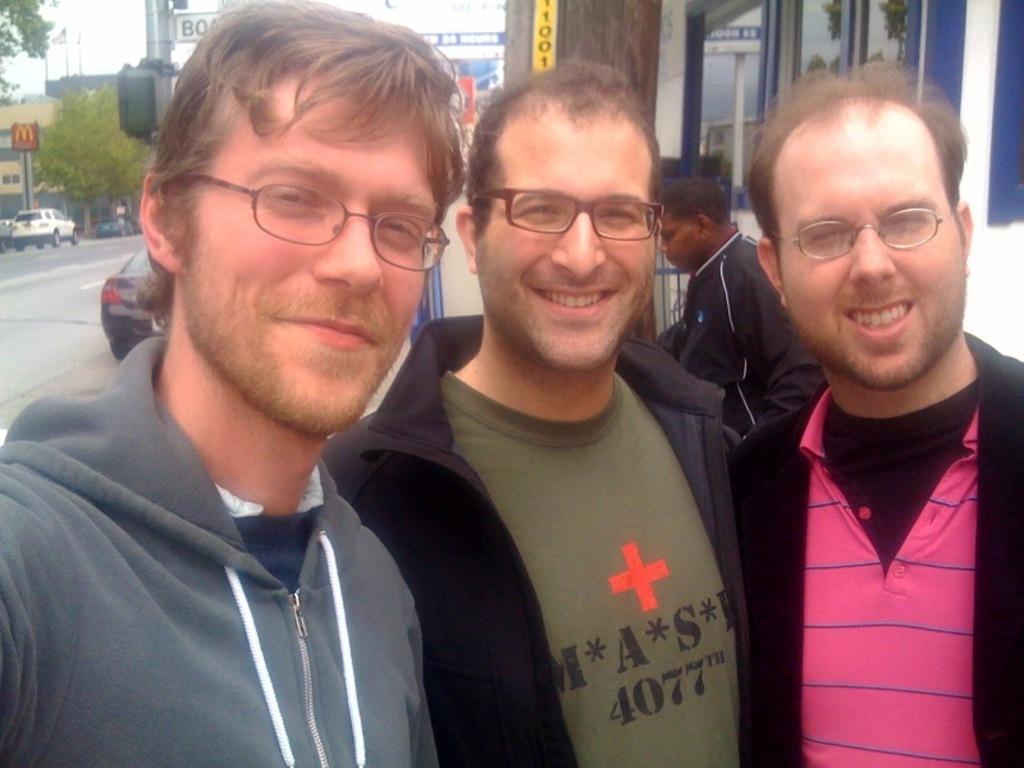Could you give a brief overview of what you see in this image? In the middle of the image three persons are standing and smiling. Behind them there are some vehicles and buildings and trees and poles and a person is standing. 